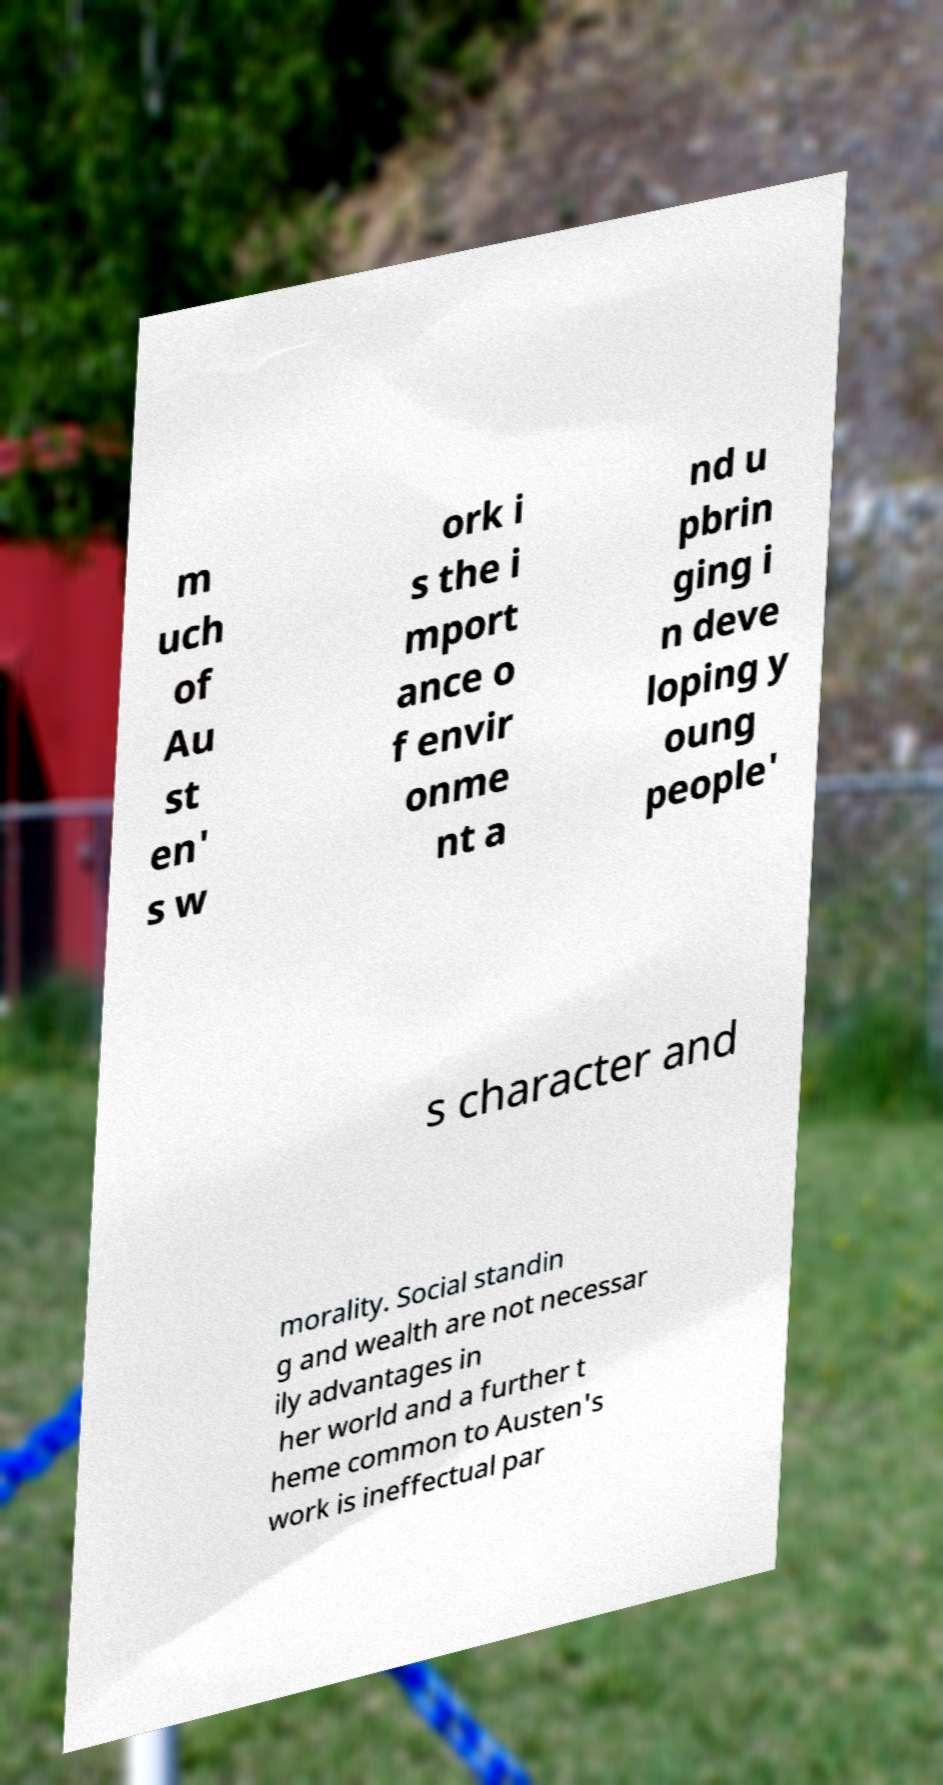Could you extract and type out the text from this image? m uch of Au st en' s w ork i s the i mport ance o f envir onme nt a nd u pbrin ging i n deve loping y oung people' s character and morality. Social standin g and wealth are not necessar ily advantages in her world and a further t heme common to Austen's work is ineffectual par 